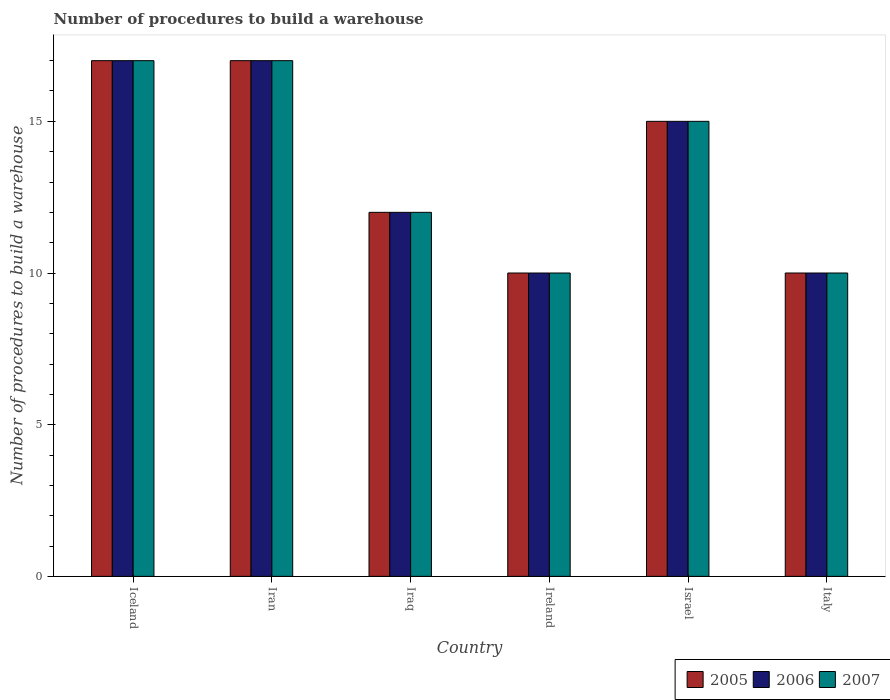How many groups of bars are there?
Provide a short and direct response. 6. Are the number of bars per tick equal to the number of legend labels?
Offer a very short reply. Yes. Are the number of bars on each tick of the X-axis equal?
Provide a succinct answer. Yes. How many bars are there on the 4th tick from the left?
Keep it short and to the point. 3. In how many cases, is the number of bars for a given country not equal to the number of legend labels?
Make the answer very short. 0. In which country was the number of procedures to build a warehouse in in 2006 minimum?
Give a very brief answer. Ireland. What is the difference between the number of procedures to build a warehouse in in 2006 in Iran and that in Israel?
Your answer should be compact. 2. What is the difference between the number of procedures to build a warehouse in of/in 2005 and number of procedures to build a warehouse in of/in 2006 in Iraq?
Your answer should be compact. 0. In how many countries, is the number of procedures to build a warehouse in in 2006 greater than 6?
Your answer should be very brief. 6. What is the ratio of the number of procedures to build a warehouse in in 2005 in Iran to that in Israel?
Your answer should be very brief. 1.13. Is the number of procedures to build a warehouse in in 2007 in Iceland less than that in Iran?
Your response must be concise. No. Is the difference between the number of procedures to build a warehouse in in 2005 in Iran and Israel greater than the difference between the number of procedures to build a warehouse in in 2006 in Iran and Israel?
Your response must be concise. No. What is the difference between the highest and the second highest number of procedures to build a warehouse in in 2006?
Keep it short and to the point. 2. Is the sum of the number of procedures to build a warehouse in in 2005 in Iceland and Iran greater than the maximum number of procedures to build a warehouse in in 2007 across all countries?
Make the answer very short. Yes. What does the 1st bar from the right in Iraq represents?
Offer a terse response. 2007. Are all the bars in the graph horizontal?
Provide a short and direct response. No. Are the values on the major ticks of Y-axis written in scientific E-notation?
Keep it short and to the point. No. Where does the legend appear in the graph?
Provide a succinct answer. Bottom right. How are the legend labels stacked?
Your response must be concise. Horizontal. What is the title of the graph?
Your answer should be very brief. Number of procedures to build a warehouse. What is the label or title of the X-axis?
Ensure brevity in your answer.  Country. What is the label or title of the Y-axis?
Your answer should be very brief. Number of procedures to build a warehouse. What is the Number of procedures to build a warehouse in 2005 in Iceland?
Your answer should be very brief. 17. What is the Number of procedures to build a warehouse in 2006 in Iceland?
Provide a short and direct response. 17. What is the Number of procedures to build a warehouse of 2006 in Iran?
Ensure brevity in your answer.  17. What is the Number of procedures to build a warehouse in 2007 in Iran?
Ensure brevity in your answer.  17. What is the Number of procedures to build a warehouse of 2006 in Iraq?
Provide a short and direct response. 12. What is the Number of procedures to build a warehouse of 2006 in Ireland?
Provide a succinct answer. 10. What is the Number of procedures to build a warehouse of 2006 in Israel?
Give a very brief answer. 15. What is the Number of procedures to build a warehouse in 2005 in Italy?
Provide a short and direct response. 10. What is the Number of procedures to build a warehouse in 2006 in Italy?
Give a very brief answer. 10. Across all countries, what is the maximum Number of procedures to build a warehouse in 2005?
Give a very brief answer. 17. Across all countries, what is the maximum Number of procedures to build a warehouse in 2007?
Provide a succinct answer. 17. Across all countries, what is the minimum Number of procedures to build a warehouse in 2005?
Your answer should be compact. 10. Across all countries, what is the minimum Number of procedures to build a warehouse in 2006?
Make the answer very short. 10. What is the total Number of procedures to build a warehouse of 2005 in the graph?
Your answer should be very brief. 81. What is the total Number of procedures to build a warehouse in 2006 in the graph?
Your answer should be very brief. 81. What is the difference between the Number of procedures to build a warehouse of 2007 in Iceland and that in Iran?
Your answer should be very brief. 0. What is the difference between the Number of procedures to build a warehouse in 2006 in Iceland and that in Iraq?
Your response must be concise. 5. What is the difference between the Number of procedures to build a warehouse in 2005 in Iceland and that in Israel?
Your answer should be very brief. 2. What is the difference between the Number of procedures to build a warehouse of 2006 in Iceland and that in Israel?
Your answer should be compact. 2. What is the difference between the Number of procedures to build a warehouse of 2005 in Iceland and that in Italy?
Provide a short and direct response. 7. What is the difference between the Number of procedures to build a warehouse of 2006 in Iceland and that in Italy?
Ensure brevity in your answer.  7. What is the difference between the Number of procedures to build a warehouse in 2005 in Iran and that in Iraq?
Give a very brief answer. 5. What is the difference between the Number of procedures to build a warehouse of 2006 in Iran and that in Iraq?
Keep it short and to the point. 5. What is the difference between the Number of procedures to build a warehouse in 2005 in Iran and that in Ireland?
Give a very brief answer. 7. What is the difference between the Number of procedures to build a warehouse in 2005 in Iran and that in Israel?
Ensure brevity in your answer.  2. What is the difference between the Number of procedures to build a warehouse of 2007 in Iran and that in Israel?
Ensure brevity in your answer.  2. What is the difference between the Number of procedures to build a warehouse of 2007 in Iran and that in Italy?
Ensure brevity in your answer.  7. What is the difference between the Number of procedures to build a warehouse of 2005 in Iraq and that in Italy?
Keep it short and to the point. 2. What is the difference between the Number of procedures to build a warehouse in 2006 in Ireland and that in Israel?
Your response must be concise. -5. What is the difference between the Number of procedures to build a warehouse in 2007 in Israel and that in Italy?
Give a very brief answer. 5. What is the difference between the Number of procedures to build a warehouse in 2005 in Iceland and the Number of procedures to build a warehouse in 2006 in Iran?
Keep it short and to the point. 0. What is the difference between the Number of procedures to build a warehouse in 2005 in Iceland and the Number of procedures to build a warehouse in 2007 in Iran?
Give a very brief answer. 0. What is the difference between the Number of procedures to build a warehouse of 2006 in Iceland and the Number of procedures to build a warehouse of 2007 in Iran?
Provide a succinct answer. 0. What is the difference between the Number of procedures to build a warehouse of 2006 in Iceland and the Number of procedures to build a warehouse of 2007 in Ireland?
Make the answer very short. 7. What is the difference between the Number of procedures to build a warehouse of 2005 in Iceland and the Number of procedures to build a warehouse of 2006 in Israel?
Give a very brief answer. 2. What is the difference between the Number of procedures to build a warehouse of 2005 in Iceland and the Number of procedures to build a warehouse of 2006 in Italy?
Provide a short and direct response. 7. What is the difference between the Number of procedures to build a warehouse in 2005 in Iceland and the Number of procedures to build a warehouse in 2007 in Italy?
Offer a very short reply. 7. What is the difference between the Number of procedures to build a warehouse in 2006 in Iceland and the Number of procedures to build a warehouse in 2007 in Italy?
Offer a very short reply. 7. What is the difference between the Number of procedures to build a warehouse of 2006 in Iran and the Number of procedures to build a warehouse of 2007 in Iraq?
Provide a succinct answer. 5. What is the difference between the Number of procedures to build a warehouse of 2006 in Iran and the Number of procedures to build a warehouse of 2007 in Ireland?
Offer a terse response. 7. What is the difference between the Number of procedures to build a warehouse in 2005 in Iran and the Number of procedures to build a warehouse in 2006 in Israel?
Offer a terse response. 2. What is the difference between the Number of procedures to build a warehouse of 2005 in Iran and the Number of procedures to build a warehouse of 2006 in Italy?
Offer a very short reply. 7. What is the difference between the Number of procedures to build a warehouse of 2005 in Iran and the Number of procedures to build a warehouse of 2007 in Italy?
Ensure brevity in your answer.  7. What is the difference between the Number of procedures to build a warehouse in 2006 in Iraq and the Number of procedures to build a warehouse in 2007 in Ireland?
Make the answer very short. 2. What is the difference between the Number of procedures to build a warehouse of 2005 in Iraq and the Number of procedures to build a warehouse of 2006 in Israel?
Make the answer very short. -3. What is the difference between the Number of procedures to build a warehouse in 2005 in Iraq and the Number of procedures to build a warehouse in 2007 in Israel?
Make the answer very short. -3. What is the difference between the Number of procedures to build a warehouse in 2005 in Iraq and the Number of procedures to build a warehouse in 2006 in Italy?
Make the answer very short. 2. What is the difference between the Number of procedures to build a warehouse in 2005 in Iraq and the Number of procedures to build a warehouse in 2007 in Italy?
Your answer should be compact. 2. What is the difference between the Number of procedures to build a warehouse of 2005 in Ireland and the Number of procedures to build a warehouse of 2006 in Israel?
Make the answer very short. -5. What is the difference between the Number of procedures to build a warehouse in 2005 in Ireland and the Number of procedures to build a warehouse in 2006 in Italy?
Make the answer very short. 0. What is the difference between the Number of procedures to build a warehouse in 2005 in Israel and the Number of procedures to build a warehouse in 2006 in Italy?
Give a very brief answer. 5. What is the difference between the Number of procedures to build a warehouse of 2005 and Number of procedures to build a warehouse of 2006 in Iceland?
Your response must be concise. 0. What is the difference between the Number of procedures to build a warehouse in 2005 and Number of procedures to build a warehouse in 2006 in Iran?
Provide a short and direct response. 0. What is the difference between the Number of procedures to build a warehouse in 2005 and Number of procedures to build a warehouse in 2007 in Iran?
Ensure brevity in your answer.  0. What is the difference between the Number of procedures to build a warehouse in 2006 and Number of procedures to build a warehouse in 2007 in Iran?
Provide a short and direct response. 0. What is the difference between the Number of procedures to build a warehouse in 2005 and Number of procedures to build a warehouse in 2006 in Iraq?
Offer a very short reply. 0. What is the difference between the Number of procedures to build a warehouse in 2005 and Number of procedures to build a warehouse in 2007 in Iraq?
Offer a terse response. 0. What is the difference between the Number of procedures to build a warehouse of 2005 and Number of procedures to build a warehouse of 2007 in Ireland?
Your answer should be very brief. 0. What is the difference between the Number of procedures to build a warehouse in 2005 and Number of procedures to build a warehouse in 2007 in Israel?
Make the answer very short. 0. What is the ratio of the Number of procedures to build a warehouse of 2005 in Iceland to that in Iran?
Make the answer very short. 1. What is the ratio of the Number of procedures to build a warehouse of 2005 in Iceland to that in Iraq?
Offer a terse response. 1.42. What is the ratio of the Number of procedures to build a warehouse of 2006 in Iceland to that in Iraq?
Ensure brevity in your answer.  1.42. What is the ratio of the Number of procedures to build a warehouse in 2007 in Iceland to that in Iraq?
Provide a short and direct response. 1.42. What is the ratio of the Number of procedures to build a warehouse of 2005 in Iceland to that in Ireland?
Your answer should be very brief. 1.7. What is the ratio of the Number of procedures to build a warehouse in 2006 in Iceland to that in Ireland?
Your answer should be very brief. 1.7. What is the ratio of the Number of procedures to build a warehouse in 2007 in Iceland to that in Ireland?
Provide a succinct answer. 1.7. What is the ratio of the Number of procedures to build a warehouse of 2005 in Iceland to that in Israel?
Give a very brief answer. 1.13. What is the ratio of the Number of procedures to build a warehouse of 2006 in Iceland to that in Israel?
Keep it short and to the point. 1.13. What is the ratio of the Number of procedures to build a warehouse in 2007 in Iceland to that in Israel?
Give a very brief answer. 1.13. What is the ratio of the Number of procedures to build a warehouse of 2005 in Iceland to that in Italy?
Provide a short and direct response. 1.7. What is the ratio of the Number of procedures to build a warehouse of 2006 in Iceland to that in Italy?
Provide a succinct answer. 1.7. What is the ratio of the Number of procedures to build a warehouse of 2005 in Iran to that in Iraq?
Ensure brevity in your answer.  1.42. What is the ratio of the Number of procedures to build a warehouse in 2006 in Iran to that in Iraq?
Make the answer very short. 1.42. What is the ratio of the Number of procedures to build a warehouse of 2007 in Iran to that in Iraq?
Your answer should be very brief. 1.42. What is the ratio of the Number of procedures to build a warehouse of 2006 in Iran to that in Ireland?
Your answer should be very brief. 1.7. What is the ratio of the Number of procedures to build a warehouse of 2007 in Iran to that in Ireland?
Offer a very short reply. 1.7. What is the ratio of the Number of procedures to build a warehouse in 2005 in Iran to that in Israel?
Ensure brevity in your answer.  1.13. What is the ratio of the Number of procedures to build a warehouse in 2006 in Iran to that in Israel?
Keep it short and to the point. 1.13. What is the ratio of the Number of procedures to build a warehouse of 2007 in Iran to that in Israel?
Ensure brevity in your answer.  1.13. What is the ratio of the Number of procedures to build a warehouse of 2005 in Iran to that in Italy?
Offer a very short reply. 1.7. What is the ratio of the Number of procedures to build a warehouse of 2006 in Iran to that in Italy?
Keep it short and to the point. 1.7. What is the ratio of the Number of procedures to build a warehouse in 2005 in Iraq to that in Ireland?
Provide a short and direct response. 1.2. What is the ratio of the Number of procedures to build a warehouse in 2007 in Iraq to that in Ireland?
Provide a succinct answer. 1.2. What is the ratio of the Number of procedures to build a warehouse in 2005 in Iraq to that in Israel?
Provide a succinct answer. 0.8. What is the ratio of the Number of procedures to build a warehouse in 2007 in Iraq to that in Italy?
Offer a very short reply. 1.2. What is the ratio of the Number of procedures to build a warehouse of 2005 in Ireland to that in Israel?
Keep it short and to the point. 0.67. What is the ratio of the Number of procedures to build a warehouse of 2006 in Ireland to that in Israel?
Offer a very short reply. 0.67. What is the ratio of the Number of procedures to build a warehouse of 2006 in Ireland to that in Italy?
Offer a terse response. 1. What is the ratio of the Number of procedures to build a warehouse in 2005 in Israel to that in Italy?
Give a very brief answer. 1.5. What is the ratio of the Number of procedures to build a warehouse in 2006 in Israel to that in Italy?
Your answer should be very brief. 1.5. What is the difference between the highest and the second highest Number of procedures to build a warehouse in 2005?
Provide a short and direct response. 0. What is the difference between the highest and the lowest Number of procedures to build a warehouse of 2005?
Your response must be concise. 7. 